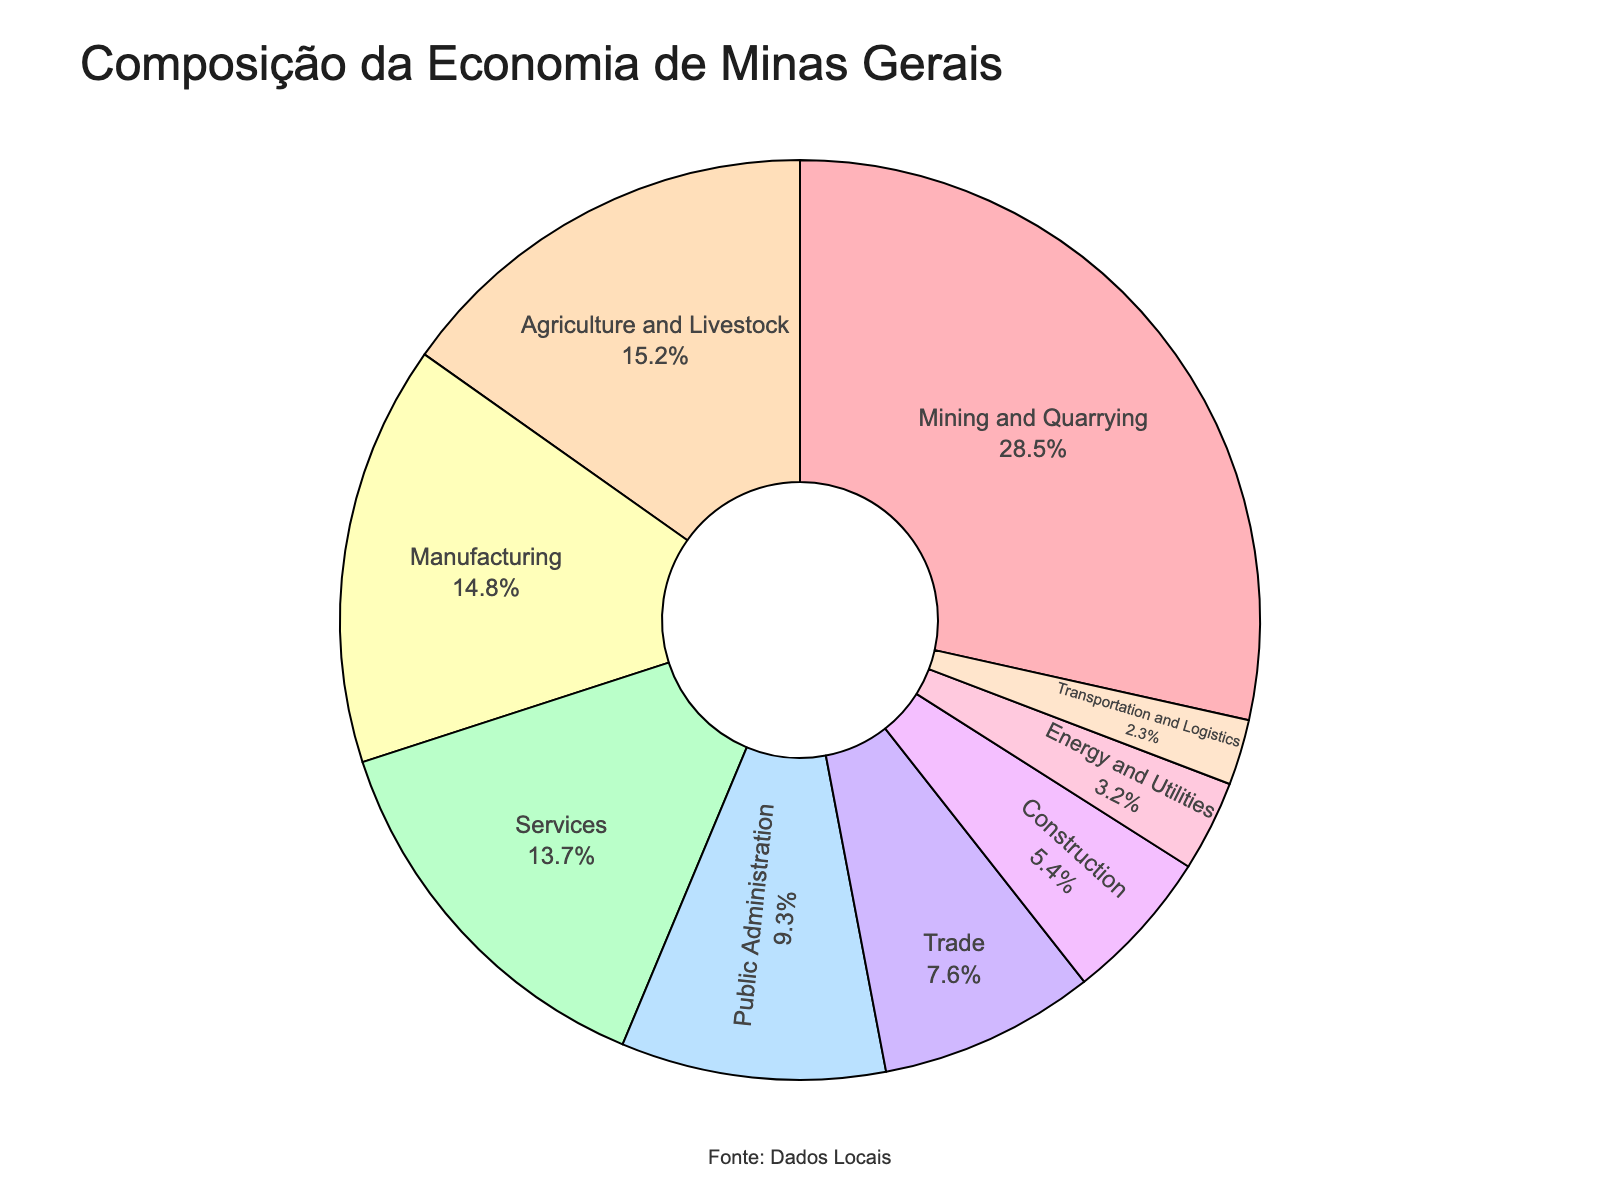What's the largest contributing sector to Minas Gerais' economy? The sector with the highest percentage in the pie chart is the largest contributor. Here, Mining and Quarrying sector has the highest percentage of 28.5%.
Answer: Mining and Quarrying What's the combined contribution of Trade, Construction, Energy and Utilities, and Transportation and Logistics sectors? To find the combined contribution, sum the percentages of these sectors: Trade (7.6) + Construction (5.4) + Energy and Utilities (3.2) + Transportation and Logistics (2.3). This equals 18.5%.
Answer: 18.5% How does the contribution of the Public Administration sector compare to the Services sector? The pie chart shows the percentage contribution of each sector. The Public Administration sector contributes 9.3%, whereas the Services sector contributes 13.7%. Therefore, the Services sector contributes 4.4% more than the Public Administration sector.
Answer: Services contributes 4.4% more Which sector has a visual representation closer in size to the Manufacturing sector? By visually comparing the sectors, Agriculture and Livestock has a percentage (15.2%) closer in size to Manufacturing (14.8%).
Answer: Agriculture and Livestock What is the percentage difference between Mining and Quarrying sector and the second largest sector? Mining and Quarrying is the largest sector at 28.5%, and Agriculture and Livestock is the second largest at 15.2%. Subtract the second largest from the largest: 28.5 - 15.2 = 13.3%.
Answer: 13.3% Which sectors are represented in hues of green? Observing the colors assigned in the pie chart, Services is represented in a hue of green.
Answer: Services How many sectors contribute less than 10% each to the economy? To answer this, count the sectors with percentages less than 10%: Public Administration (9.3%), Trade (7.6%), Construction (5.4%), Energy and Utilities (3.2%), and Transportation and Logistics (2.3%). This gives a total of 5 sectors.
Answer: 5 sectors What is the percentage contribution of all sectors other than Mining and Quarrying and Agriculture and Livestock? To find this, subtract the contributions of Mining and Quarrying (28.5%) and Agriculture and Livestock (15.2%) from 100%. 100 - 28.5 - 15.2 = 56.3%.
Answer: 56.3% Is the combined contribution of Manufacturing and Services sectors higher than Mining and Quarrying sector? Yes, combine Manufacturing (14.8%) and Services (13.7%) to get 28.5%. This is equal to Mining and Quarrying, not higher.
Answer: No, it's equal 